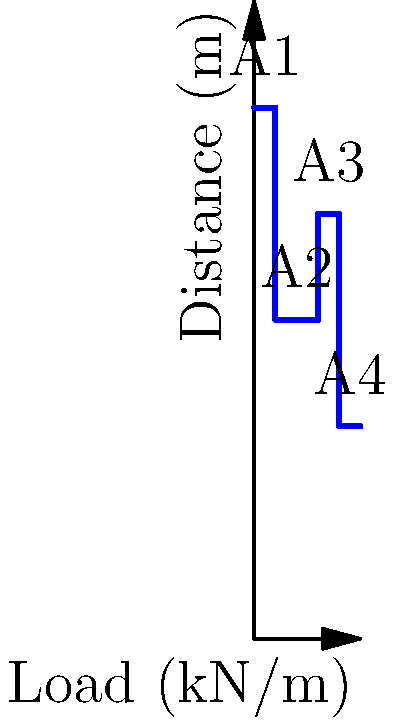Based on the load diagram shown, determine the maximum spacing of reinforcement bars in a concrete slab if the maximum allowable bending moment is 150 kN⋅m and the effective depth of the slab is 200 mm. Assume a simplified analysis where the maximum moment occurs at the point of maximum load. To determine the optimal spacing of reinforcement bars, we need to follow these steps:

1. Calculate the total load:
   Area A1: $50 \times 2 = 100$ kN/m
   Area A2: $30 \times 4 = 120$ kN/m
   Area A3: $40 \times 2 = 80$ kN/m
   Area A4: $20 \times 2 = 40$ kN/m
   Total load = $100 + 120 + 80 + 40 = 340$ kN/m

2. Find the average load:
   Average load = $\frac{340}{10} = 34$ kN/m

3. Calculate the maximum bending moment:
   $M_{max} = \frac{wL^2}{8}$, where $w$ is the average load and $L$ is the span
   $150 = \frac{34L^2}{8}$
   $L^2 = \frac{150 \times 8}{34} = 35.29$
   $L = \sqrt{35.29} = 5.94$ m

4. Determine the required area of steel:
   $A_s = \frac{M}{0.87f_y z}$, where $f_y$ is the yield strength of steel (assume 500 MPa) and $z$ is the lever arm (assume 0.9d)
   $A_s = \frac{150 \times 10^6}{0.87 \times 500 \times 0.9 \times 200} = 1916$ mm²/m

5. Calculate the spacing of bars:
   Assuming 16 mm diameter bars, area of one bar = $\pi \times 8^2 = 201$ mm²
   Number of bars per meter = $\frac{1916}{201} = 9.53$
   Spacing = $\frac{1000}{9.53} = 104.9$ mm

Therefore, the maximum spacing of reinforcement bars should be 100 mm (rounded down for practical purposes).
Answer: 100 mm 